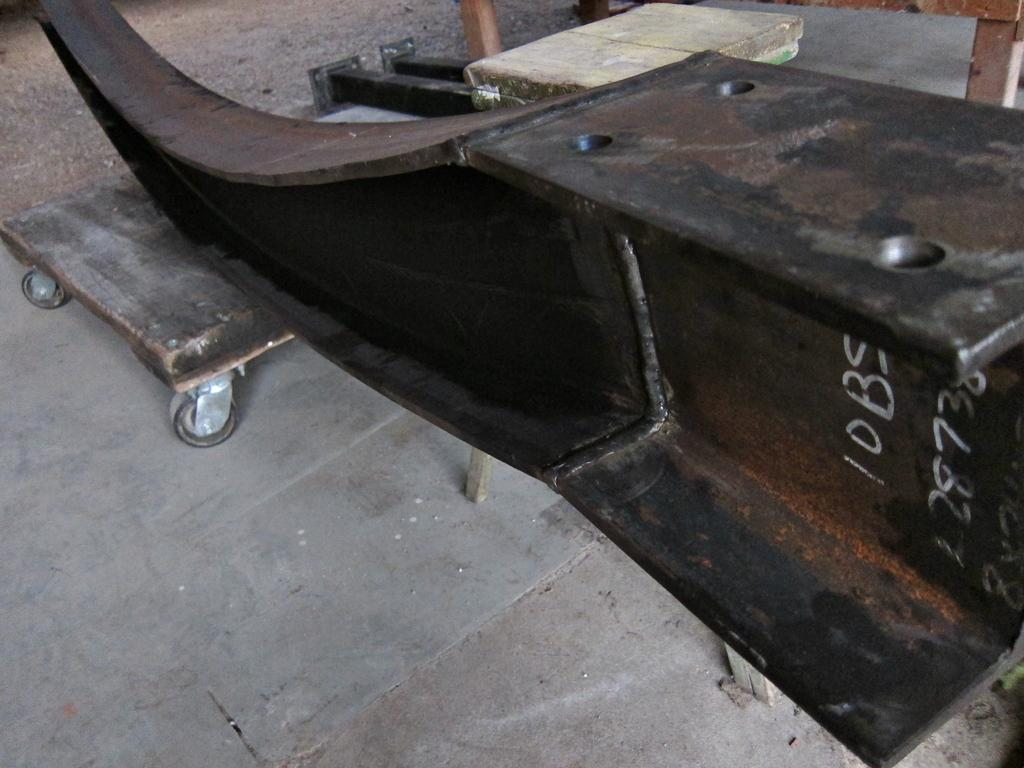What is the color of the object in the image? The object in the image is brown in color. What is located in front of the object? There is a wooden trolley in front of the object. What type of substance is being transported by the airplane in the image? There is no airplane present in the image, so it is not possible to determine what, if any, substance might be transported by an airplane. 